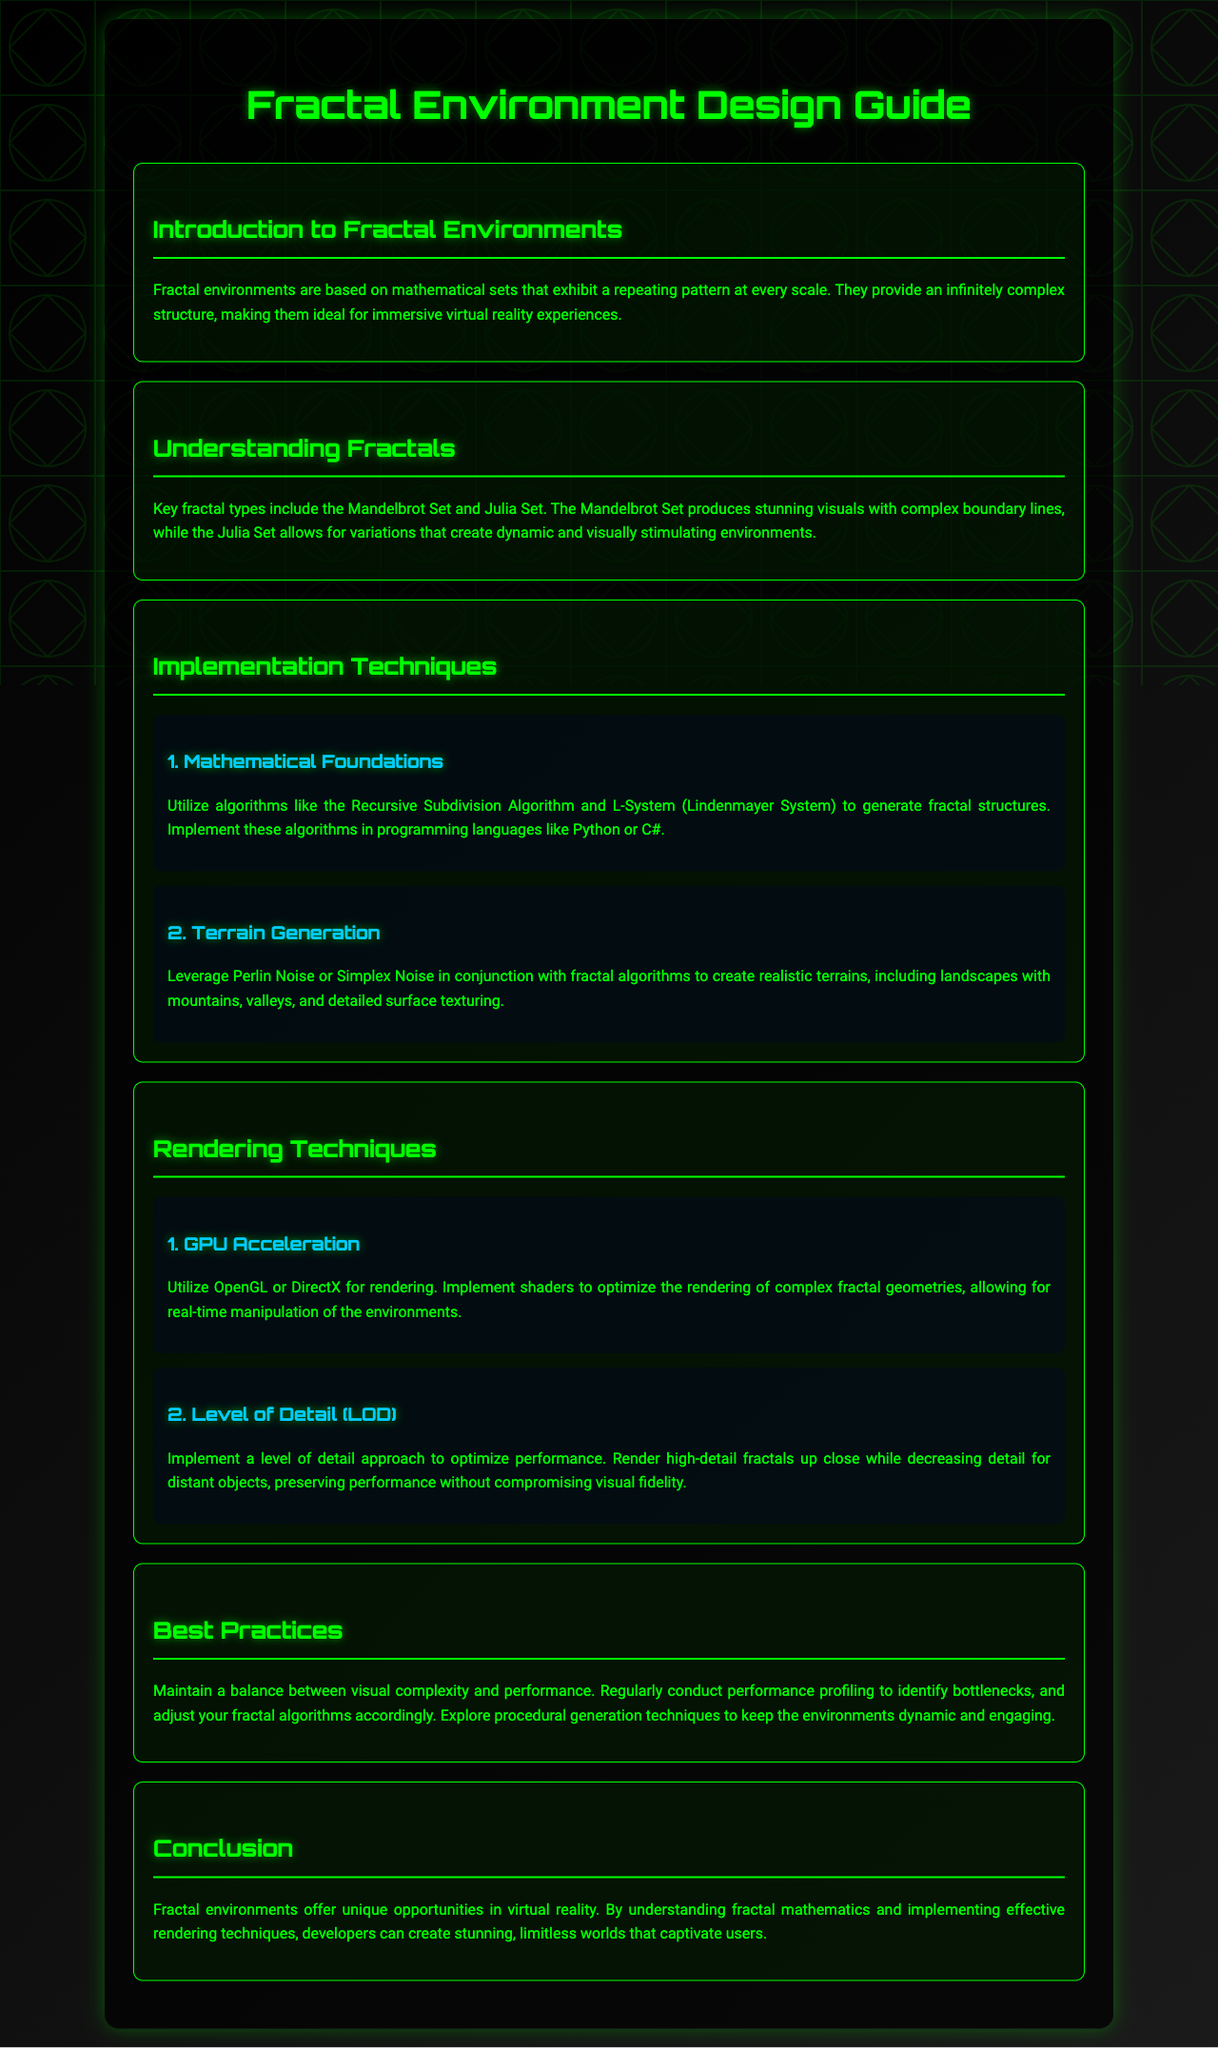What are fractal environments based on? Fractal environments are based on mathematical sets that exhibit a repeating pattern at every scale.
Answer: mathematical sets What key fractal type produces stunning visuals? The key fractal type that produces stunning visuals is mentioned in the section on understanding fractals.
Answer: Mandelbrot Set What algorithm can be used for terrain generation? The document states algorithms for terrain generation in the implementation techniques section.
Answer: Perlin Noise Which rendering technique uses OpenGL or DirectX? This is referred to in the rendering techniques section, specifically under GPU acceleration.
Answer: GPU Acceleration What is the main focus of best practices in fractal environments? The best practices section highlights the main focus developers should maintain.
Answer: balance between visual complexity and performance Which algorithm is mentioned for generating fractal structures? The implementation techniques section provides algorithms used to generate fractal structures.
Answer: Recursive Subdivision Algorithm What is one benefit of using Level of Detail? The rendering techniques section discusses the benefit of implementing Level of Detail.
Answer: optimize performance What is a characteristic of fractal environments mentioned in the conclusion? The conclusion provides unique opportunities relating to fractal environments in virtual reality.
Answer: stunning, limitless worlds How many implementations techniques are specified? The implementation techniques include two subsections detailing different methods.
Answer: 2 